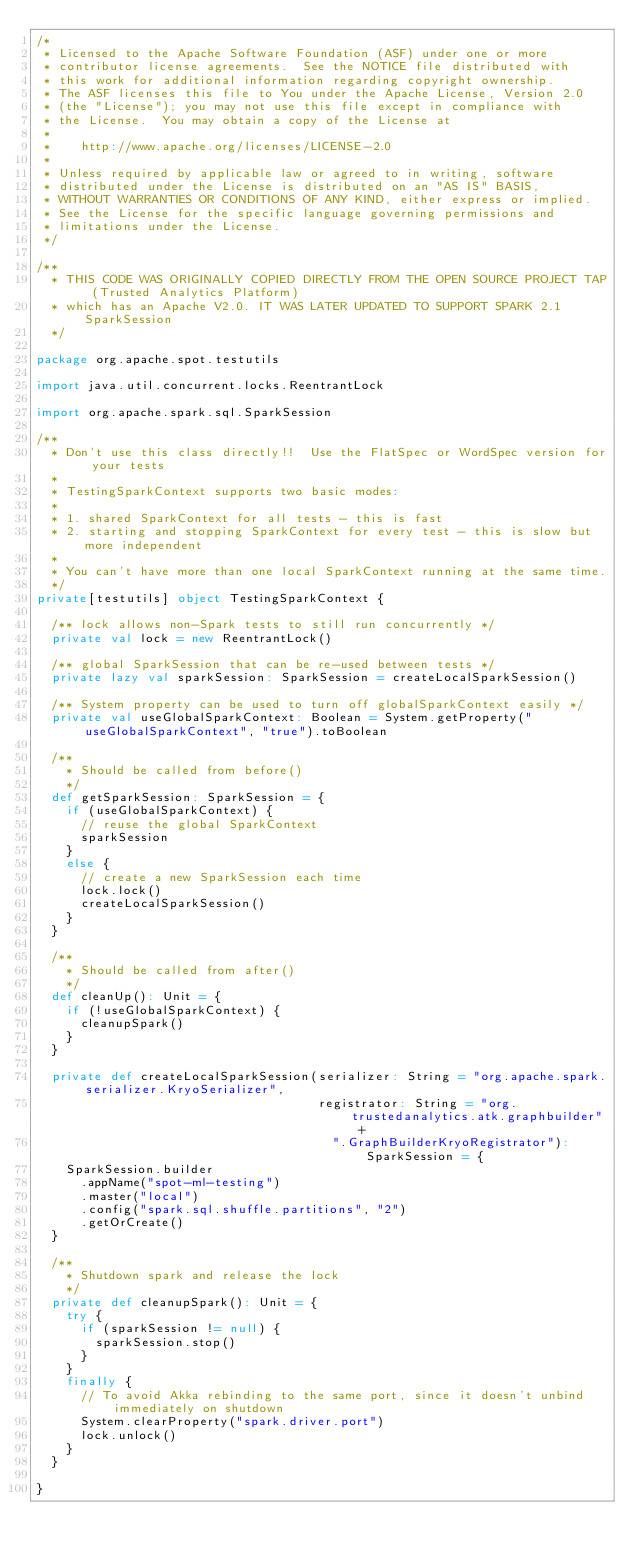Convert code to text. <code><loc_0><loc_0><loc_500><loc_500><_Scala_>/*
 * Licensed to the Apache Software Foundation (ASF) under one or more
 * contributor license agreements.  See the NOTICE file distributed with
 * this work for additional information regarding copyright ownership.
 * The ASF licenses this file to You under the Apache License, Version 2.0
 * (the "License"); you may not use this file except in compliance with
 * the License.  You may obtain a copy of the License at
 *
 *    http://www.apache.org/licenses/LICENSE-2.0
 *
 * Unless required by applicable law or agreed to in writing, software
 * distributed under the License is distributed on an "AS IS" BASIS,
 * WITHOUT WARRANTIES OR CONDITIONS OF ANY KIND, either express or implied.
 * See the License for the specific language governing permissions and
 * limitations under the License.
 */

/**
  * THIS CODE WAS ORIGINALLY COPIED DIRECTLY FROM THE OPEN SOURCE PROJECT TAP (Trusted Analytics Platform)
  * which has an Apache V2.0. IT WAS LATER UPDATED TO SUPPORT SPARK 2.1 SparkSession
  */

package org.apache.spot.testutils

import java.util.concurrent.locks.ReentrantLock

import org.apache.spark.sql.SparkSession

/**
  * Don't use this class directly!!  Use the FlatSpec or WordSpec version for your tests
  *
  * TestingSparkContext supports two basic modes:
  *
  * 1. shared SparkContext for all tests - this is fast
  * 2. starting and stopping SparkContext for every test - this is slow but more independent
  *
  * You can't have more than one local SparkContext running at the same time.
  */
private[testutils] object TestingSparkContext {

  /** lock allows non-Spark tests to still run concurrently */
  private val lock = new ReentrantLock()

  /** global SparkSession that can be re-used between tests */
  private lazy val sparkSession: SparkSession = createLocalSparkSession()

  /** System property can be used to turn off globalSparkContext easily */
  private val useGlobalSparkContext: Boolean = System.getProperty("useGlobalSparkContext", "true").toBoolean

  /**
    * Should be called from before()
    */
  def getSparkSession: SparkSession = {
    if (useGlobalSparkContext) {
      // reuse the global SparkContext
      sparkSession
    }
    else {
      // create a new SparkSession each time
      lock.lock()
      createLocalSparkSession()
    }
  }

  /**
    * Should be called from after()
    */
  def cleanUp(): Unit = {
    if (!useGlobalSparkContext) {
      cleanupSpark()
    }
  }

  private def createLocalSparkSession(serializer: String = "org.apache.spark.serializer.KryoSerializer",
                                      registrator: String = "org.trustedanalytics.atk.graphbuilder" +
                                        ".GraphBuilderKryoRegistrator"): SparkSession = {
    SparkSession.builder
      .appName("spot-ml-testing")
      .master("local")
      .config("spark.sql.shuffle.partitions", "2")
      .getOrCreate()
  }

  /**
    * Shutdown spark and release the lock
    */
  private def cleanupSpark(): Unit = {
    try {
      if (sparkSession != null) {
        sparkSession.stop()
      }
    }
    finally {
      // To avoid Akka rebinding to the same port, since it doesn't unbind immediately on shutdown
      System.clearProperty("spark.driver.port")
      lock.unlock()
    }
  }

}
</code> 